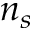Convert formula to latex. <formula><loc_0><loc_0><loc_500><loc_500>n _ { s }</formula> 